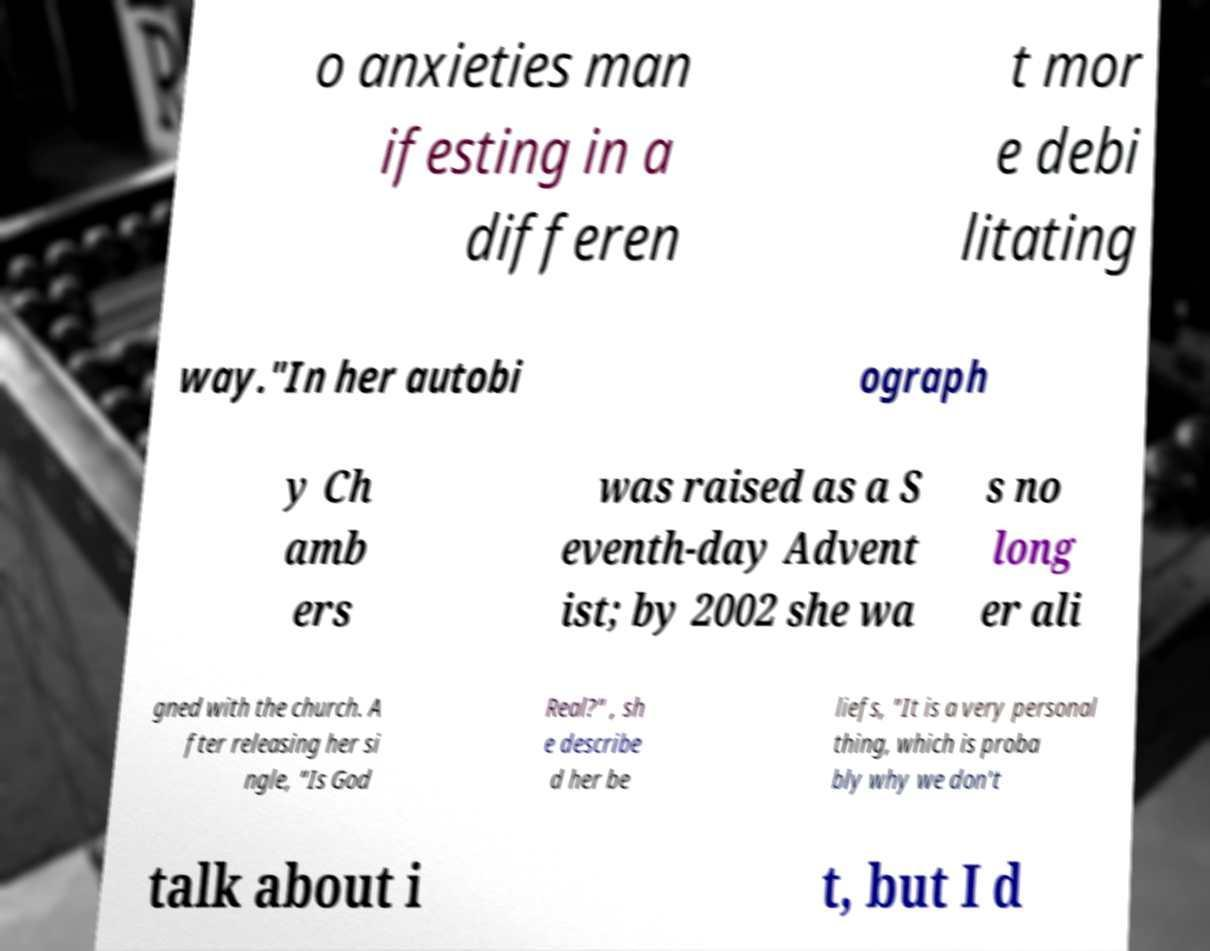Could you assist in decoding the text presented in this image and type it out clearly? o anxieties man ifesting in a differen t mor e debi litating way."In her autobi ograph y Ch amb ers was raised as a S eventh-day Advent ist; by 2002 she wa s no long er ali gned with the church. A fter releasing her si ngle, "Is God Real?" , sh e describe d her be liefs, "It is a very personal thing, which is proba bly why we don't talk about i t, but I d 